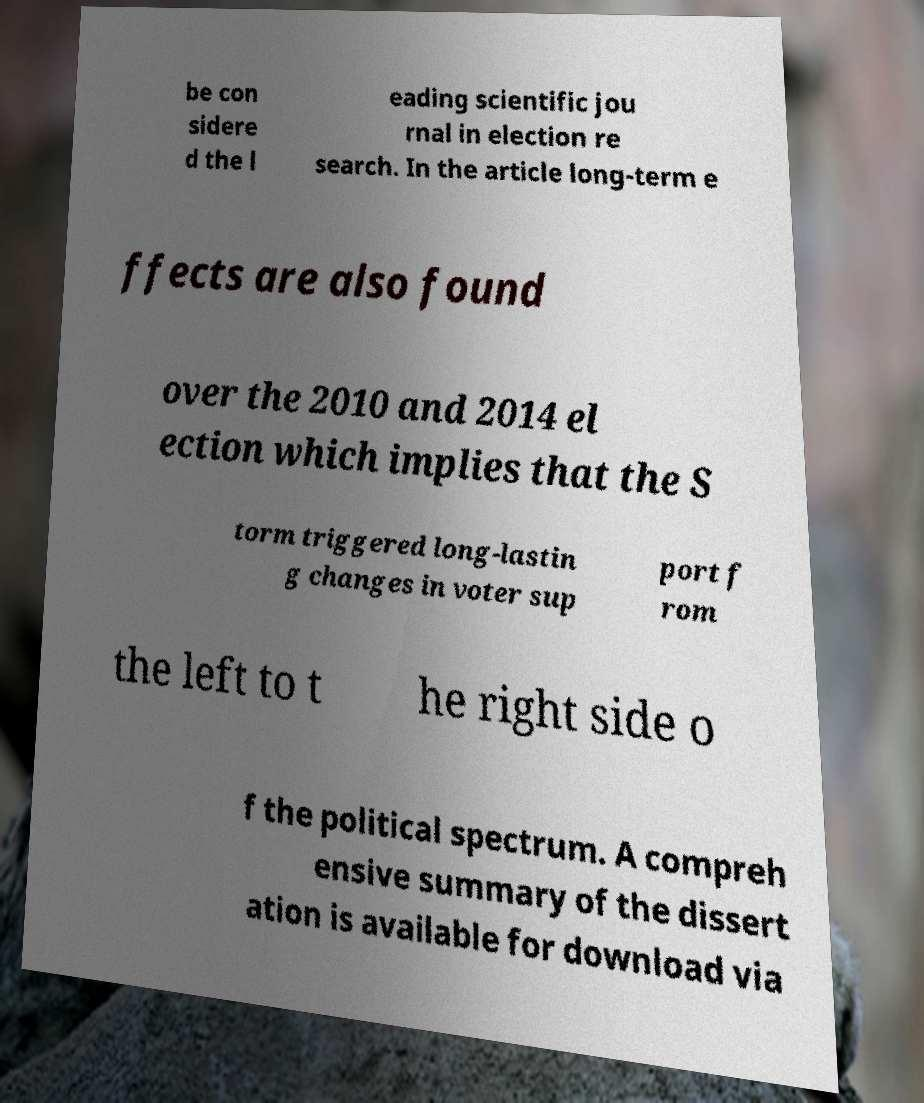Could you assist in decoding the text presented in this image and type it out clearly? be con sidere d the l eading scientific jou rnal in election re search. In the article long-term e ffects are also found over the 2010 and 2014 el ection which implies that the S torm triggered long-lastin g changes in voter sup port f rom the left to t he right side o f the political spectrum. A compreh ensive summary of the dissert ation is available for download via 